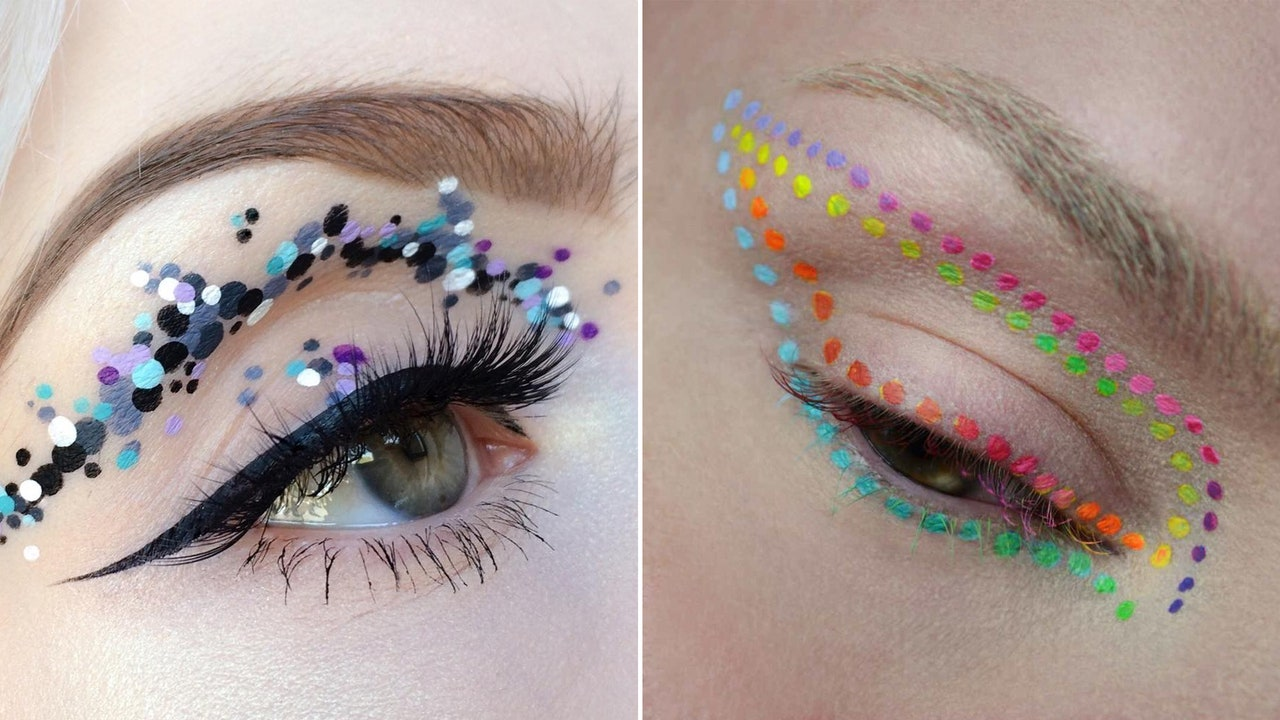Could you explain the techniques used to achieve this eyelook? To achieve these eye makeup looks, various advanced techniques are employed. Firstly, precise application is critical, using small brushes or tools for detailed placement of sequins and dots. Alongside, blending vibrant eyeshadows seamlessly is key to creating a cohesive look. Further, the use of adhesives that are safe for skin is essential to affix sequins without damage. The overall effect requires both creative vision and meticulous attention to detail. 